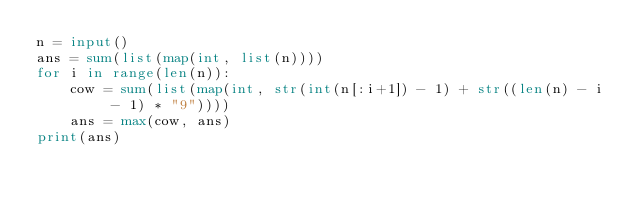<code> <loc_0><loc_0><loc_500><loc_500><_Python_>n = input()
ans = sum(list(map(int, list(n))))
for i in range(len(n)):
    cow = sum(list(map(int, str(int(n[:i+1]) - 1) + str((len(n) - i - 1) * "9"))))
    ans = max(cow, ans)
print(ans)</code> 